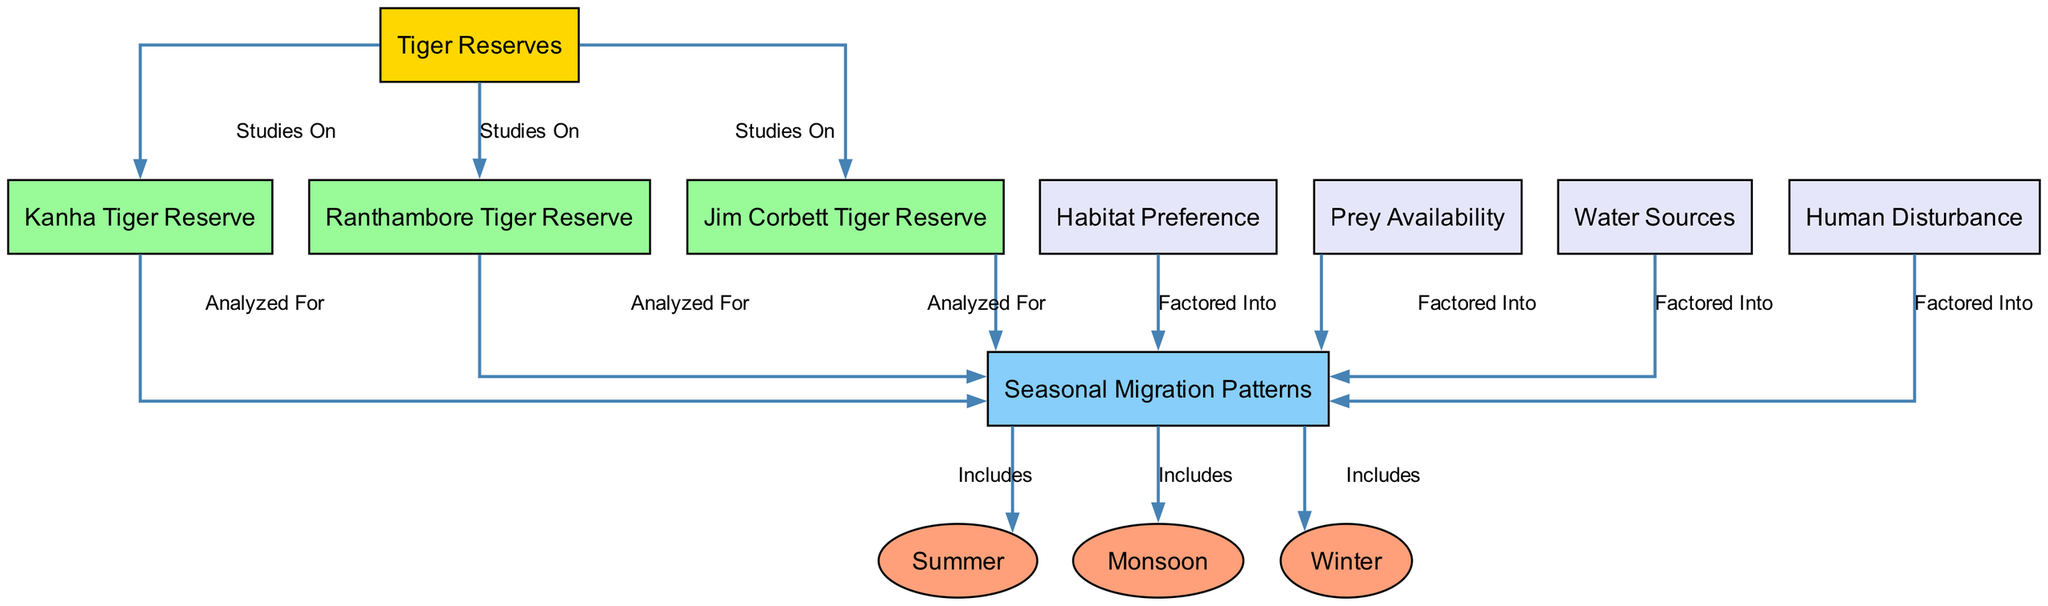What are the three seasons indicated in the diagram? The diagram includes three nodes under the "Seasonal Migration Patterns" label: summer, monsoon, and winter. These nodes are directly connected to the seasonal patterns node and clearly represent the different seasons of tiger migration.
Answer: Summer, Monsoon, Winter How many tiger reserves are studied in this diagram? The diagram lists three tiger reserves that are analyzed for seasonal patterns: Kanha Tiger Reserve, Ranthambore Tiger Reserve, and Jim Corbett Tiger Reserve. Each of these reserves is linked to the tiger reserve node, demonstrating that they are part of the study.
Answer: Three Which factor is factored into the seasonal patterns and relates to the availability of food? Among the factors shown, prey availability is specifically mentioned as a factor that influences seasonal patterns, indicating its importance in the ecology of tigers during their migration.
Answer: Prey Availability Which tiger reserve is connected to the seasonal patterns analysis first? The edges illustrate that Kanha Tiger Reserve, Ranthambore Tiger Reserve, and Jim Corbett Tiger Reserve are all analyzed for seasonal patterns. The first listed is Kanha Tiger Reserve, as it appears first in the diagram's layout.
Answer: Kanha Tiger Reserve What type of factor affects the seasonal migration patterns involving water? Water sources are shown as a factor that is factored into the seasonal migration patterns of tigers. This indicates that their migration behavior is likely influenced by the availability of water in their habitat.
Answer: Water Sources Which human-related factor is included in the study of seasonal migration patterns? Human disturbance is explicitly stated as a factor that is considered within the analysis of seasonal migration patterns, suggesting that human activities impact tiger behavior and movements in the wild.
Answer: Human Disturbance How many edges connect the seasonal patterns to the factors that are factored into it? The diagram illustrates four edges leading into the seasonal patterns node from habitat preference, prey availability, water sources, and human disturbance. This indicates that these four factors are considered when analyzing migration patterns.
Answer: Four Which reserve is visually distinct with a different color compared to others? The Kanha Tiger Reserve, Ranthambore Tiger Reserve, and Jim Corbett Tiger Reserve are colored in light green, while the seasonal patterns node is light blue. Therefore, if the question is about visual distinction, the seasonal patterns node could be considered distinct in color.
Answer: Seasonal Patterns What is the nature of the relationships displayed between the tiger reserves and seasonal patterns? The relationships shown between the tiger reserves and seasonal patterns are defined by the edges labeled "Analyzed For," indicating that the migration patterns in each reserve are being studied for seasonal variations.
Answer: Analyzed For 